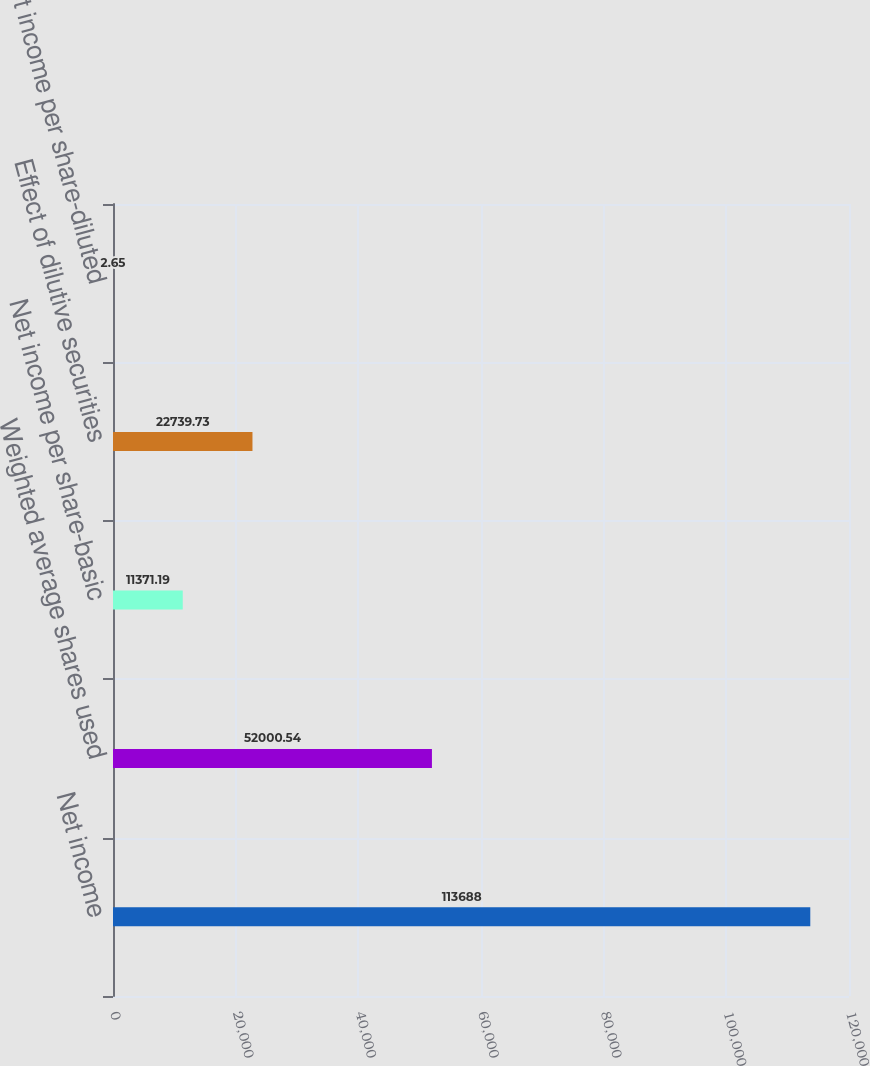<chart> <loc_0><loc_0><loc_500><loc_500><bar_chart><fcel>Net income<fcel>Weighted average shares used<fcel>Net income per share-basic<fcel>Effect of dilutive securities<fcel>Net income per share-diluted<nl><fcel>113688<fcel>52000.5<fcel>11371.2<fcel>22739.7<fcel>2.65<nl></chart> 